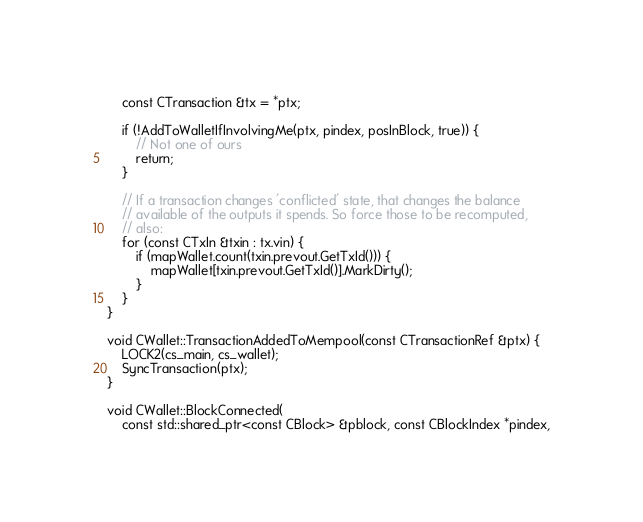Convert code to text. <code><loc_0><loc_0><loc_500><loc_500><_C++_>    const CTransaction &tx = *ptx;

    if (!AddToWalletIfInvolvingMe(ptx, pindex, posInBlock, true)) {
        // Not one of ours
        return;
    }

    // If a transaction changes 'conflicted' state, that changes the balance
    // available of the outputs it spends. So force those to be recomputed,
    // also:
    for (const CTxIn &txin : tx.vin) {
        if (mapWallet.count(txin.prevout.GetTxId())) {
            mapWallet[txin.prevout.GetTxId()].MarkDirty();
        }
    }
}

void CWallet::TransactionAddedToMempool(const CTransactionRef &ptx) {
    LOCK2(cs_main, cs_wallet);
    SyncTransaction(ptx);
}

void CWallet::BlockConnected(
    const std::shared_ptr<const CBlock> &pblock, const CBlockIndex *pindex,</code> 